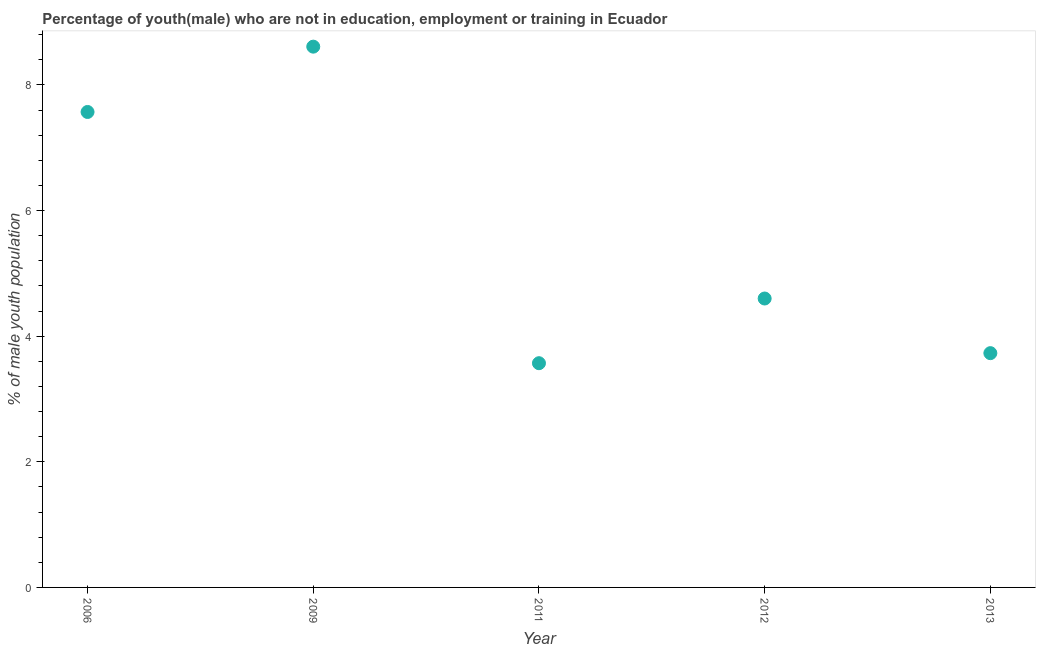What is the unemployed male youth population in 2011?
Give a very brief answer. 3.57. Across all years, what is the maximum unemployed male youth population?
Provide a succinct answer. 8.61. Across all years, what is the minimum unemployed male youth population?
Your answer should be very brief. 3.57. In which year was the unemployed male youth population maximum?
Your answer should be compact. 2009. What is the sum of the unemployed male youth population?
Ensure brevity in your answer.  28.08. What is the difference between the unemployed male youth population in 2009 and 2011?
Your answer should be very brief. 5.04. What is the average unemployed male youth population per year?
Provide a short and direct response. 5.62. What is the median unemployed male youth population?
Your response must be concise. 4.6. What is the ratio of the unemployed male youth population in 2012 to that in 2013?
Keep it short and to the point. 1.23. Is the unemployed male youth population in 2012 less than that in 2013?
Your answer should be compact. No. Is the difference between the unemployed male youth population in 2006 and 2011 greater than the difference between any two years?
Your answer should be compact. No. What is the difference between the highest and the second highest unemployed male youth population?
Offer a terse response. 1.04. Is the sum of the unemployed male youth population in 2009 and 2011 greater than the maximum unemployed male youth population across all years?
Your response must be concise. Yes. What is the difference between the highest and the lowest unemployed male youth population?
Keep it short and to the point. 5.04. In how many years, is the unemployed male youth population greater than the average unemployed male youth population taken over all years?
Ensure brevity in your answer.  2. Does the unemployed male youth population monotonically increase over the years?
Provide a short and direct response. No. How many years are there in the graph?
Your answer should be compact. 5. What is the difference between two consecutive major ticks on the Y-axis?
Your answer should be compact. 2. Are the values on the major ticks of Y-axis written in scientific E-notation?
Your response must be concise. No. Does the graph contain grids?
Provide a short and direct response. No. What is the title of the graph?
Offer a very short reply. Percentage of youth(male) who are not in education, employment or training in Ecuador. What is the label or title of the Y-axis?
Keep it short and to the point. % of male youth population. What is the % of male youth population in 2006?
Your response must be concise. 7.57. What is the % of male youth population in 2009?
Offer a very short reply. 8.61. What is the % of male youth population in 2011?
Make the answer very short. 3.57. What is the % of male youth population in 2012?
Ensure brevity in your answer.  4.6. What is the % of male youth population in 2013?
Ensure brevity in your answer.  3.73. What is the difference between the % of male youth population in 2006 and 2009?
Your answer should be compact. -1.04. What is the difference between the % of male youth population in 2006 and 2012?
Provide a succinct answer. 2.97. What is the difference between the % of male youth population in 2006 and 2013?
Your answer should be very brief. 3.84. What is the difference between the % of male youth population in 2009 and 2011?
Keep it short and to the point. 5.04. What is the difference between the % of male youth population in 2009 and 2012?
Make the answer very short. 4.01. What is the difference between the % of male youth population in 2009 and 2013?
Provide a short and direct response. 4.88. What is the difference between the % of male youth population in 2011 and 2012?
Your response must be concise. -1.03. What is the difference between the % of male youth population in 2011 and 2013?
Ensure brevity in your answer.  -0.16. What is the difference between the % of male youth population in 2012 and 2013?
Your response must be concise. 0.87. What is the ratio of the % of male youth population in 2006 to that in 2009?
Your answer should be very brief. 0.88. What is the ratio of the % of male youth population in 2006 to that in 2011?
Your answer should be very brief. 2.12. What is the ratio of the % of male youth population in 2006 to that in 2012?
Ensure brevity in your answer.  1.65. What is the ratio of the % of male youth population in 2006 to that in 2013?
Ensure brevity in your answer.  2.03. What is the ratio of the % of male youth population in 2009 to that in 2011?
Your answer should be compact. 2.41. What is the ratio of the % of male youth population in 2009 to that in 2012?
Provide a succinct answer. 1.87. What is the ratio of the % of male youth population in 2009 to that in 2013?
Make the answer very short. 2.31. What is the ratio of the % of male youth population in 2011 to that in 2012?
Keep it short and to the point. 0.78. What is the ratio of the % of male youth population in 2012 to that in 2013?
Your response must be concise. 1.23. 